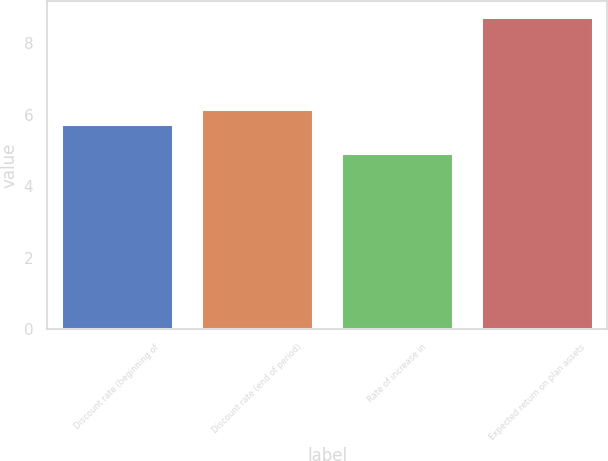Convert chart. <chart><loc_0><loc_0><loc_500><loc_500><bar_chart><fcel>Discount rate (beginning of<fcel>Discount rate (end of period)<fcel>Rate of increase in<fcel>Expected return on plan assets<nl><fcel>5.75<fcel>6.17<fcel>4.92<fcel>8.75<nl></chart> 